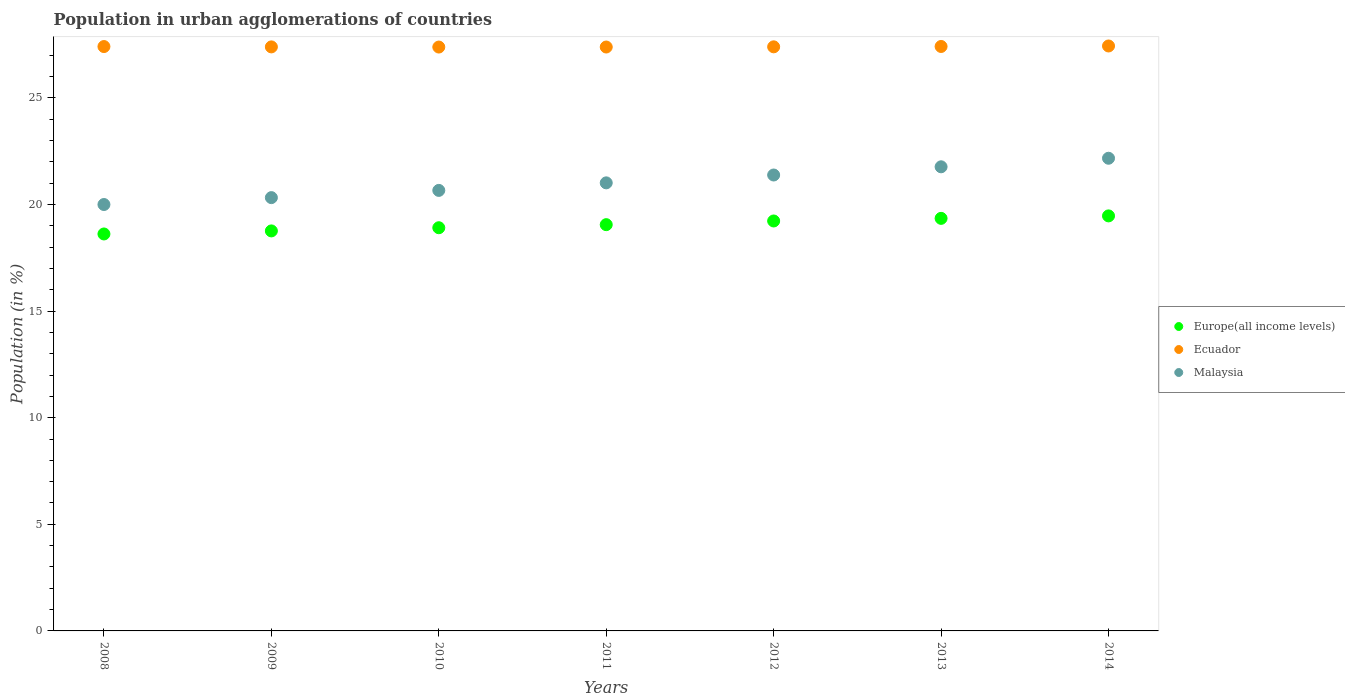How many different coloured dotlines are there?
Your response must be concise. 3. What is the percentage of population in urban agglomerations in Europe(all income levels) in 2010?
Provide a succinct answer. 18.91. Across all years, what is the maximum percentage of population in urban agglomerations in Malaysia?
Keep it short and to the point. 22.17. Across all years, what is the minimum percentage of population in urban agglomerations in Ecuador?
Keep it short and to the point. 27.39. In which year was the percentage of population in urban agglomerations in Ecuador minimum?
Offer a terse response. 2010. What is the total percentage of population in urban agglomerations in Ecuador in the graph?
Offer a very short reply. 191.82. What is the difference between the percentage of population in urban agglomerations in Europe(all income levels) in 2011 and that in 2013?
Your response must be concise. -0.3. What is the difference between the percentage of population in urban agglomerations in Ecuador in 2008 and the percentage of population in urban agglomerations in Malaysia in 2012?
Ensure brevity in your answer.  6.02. What is the average percentage of population in urban agglomerations in Ecuador per year?
Make the answer very short. 27.4. In the year 2008, what is the difference between the percentage of population in urban agglomerations in Europe(all income levels) and percentage of population in urban agglomerations in Malaysia?
Give a very brief answer. -1.38. What is the ratio of the percentage of population in urban agglomerations in Europe(all income levels) in 2009 to that in 2014?
Offer a very short reply. 0.96. What is the difference between the highest and the second highest percentage of population in urban agglomerations in Ecuador?
Keep it short and to the point. 0.02. What is the difference between the highest and the lowest percentage of population in urban agglomerations in Ecuador?
Ensure brevity in your answer.  0.05. Is the sum of the percentage of population in urban agglomerations in Malaysia in 2010 and 2011 greater than the maximum percentage of population in urban agglomerations in Ecuador across all years?
Offer a terse response. Yes. Is it the case that in every year, the sum of the percentage of population in urban agglomerations in Europe(all income levels) and percentage of population in urban agglomerations in Malaysia  is greater than the percentage of population in urban agglomerations in Ecuador?
Provide a succinct answer. Yes. Does the percentage of population in urban agglomerations in Ecuador monotonically increase over the years?
Make the answer very short. No. Is the percentage of population in urban agglomerations in Europe(all income levels) strictly less than the percentage of population in urban agglomerations in Malaysia over the years?
Your answer should be very brief. Yes. How many years are there in the graph?
Your answer should be very brief. 7. What is the title of the graph?
Provide a succinct answer. Population in urban agglomerations of countries. What is the label or title of the X-axis?
Your response must be concise. Years. What is the Population (in %) of Europe(all income levels) in 2008?
Your answer should be compact. 18.62. What is the Population (in %) of Ecuador in 2008?
Give a very brief answer. 27.41. What is the Population (in %) in Malaysia in 2008?
Give a very brief answer. 20. What is the Population (in %) of Europe(all income levels) in 2009?
Give a very brief answer. 18.76. What is the Population (in %) of Ecuador in 2009?
Your response must be concise. 27.39. What is the Population (in %) in Malaysia in 2009?
Provide a succinct answer. 20.32. What is the Population (in %) in Europe(all income levels) in 2010?
Make the answer very short. 18.91. What is the Population (in %) of Ecuador in 2010?
Make the answer very short. 27.39. What is the Population (in %) of Malaysia in 2010?
Your answer should be compact. 20.66. What is the Population (in %) in Europe(all income levels) in 2011?
Your answer should be compact. 19.06. What is the Population (in %) of Ecuador in 2011?
Your answer should be very brief. 27.39. What is the Population (in %) of Malaysia in 2011?
Keep it short and to the point. 21.02. What is the Population (in %) in Europe(all income levels) in 2012?
Provide a short and direct response. 19.23. What is the Population (in %) of Ecuador in 2012?
Offer a very short reply. 27.4. What is the Population (in %) of Malaysia in 2012?
Provide a short and direct response. 21.38. What is the Population (in %) of Europe(all income levels) in 2013?
Provide a short and direct response. 19.35. What is the Population (in %) in Ecuador in 2013?
Give a very brief answer. 27.41. What is the Population (in %) in Malaysia in 2013?
Give a very brief answer. 21.77. What is the Population (in %) of Europe(all income levels) in 2014?
Ensure brevity in your answer.  19.47. What is the Population (in %) of Ecuador in 2014?
Your response must be concise. 27.44. What is the Population (in %) of Malaysia in 2014?
Your answer should be very brief. 22.17. Across all years, what is the maximum Population (in %) in Europe(all income levels)?
Provide a short and direct response. 19.47. Across all years, what is the maximum Population (in %) in Ecuador?
Make the answer very short. 27.44. Across all years, what is the maximum Population (in %) in Malaysia?
Give a very brief answer. 22.17. Across all years, what is the minimum Population (in %) of Europe(all income levels)?
Your answer should be very brief. 18.62. Across all years, what is the minimum Population (in %) in Ecuador?
Your answer should be very brief. 27.39. Across all years, what is the minimum Population (in %) in Malaysia?
Your answer should be compact. 20. What is the total Population (in %) of Europe(all income levels) in the graph?
Your answer should be very brief. 133.39. What is the total Population (in %) of Ecuador in the graph?
Your response must be concise. 191.82. What is the total Population (in %) of Malaysia in the graph?
Provide a short and direct response. 147.32. What is the difference between the Population (in %) of Europe(all income levels) in 2008 and that in 2009?
Your answer should be compact. -0.14. What is the difference between the Population (in %) of Ecuador in 2008 and that in 2009?
Keep it short and to the point. 0.02. What is the difference between the Population (in %) of Malaysia in 2008 and that in 2009?
Give a very brief answer. -0.32. What is the difference between the Population (in %) of Europe(all income levels) in 2008 and that in 2010?
Your answer should be compact. -0.29. What is the difference between the Population (in %) in Ecuador in 2008 and that in 2010?
Ensure brevity in your answer.  0.02. What is the difference between the Population (in %) in Malaysia in 2008 and that in 2010?
Your answer should be compact. -0.66. What is the difference between the Population (in %) in Europe(all income levels) in 2008 and that in 2011?
Provide a succinct answer. -0.44. What is the difference between the Population (in %) in Ecuador in 2008 and that in 2011?
Your answer should be compact. 0.02. What is the difference between the Population (in %) of Malaysia in 2008 and that in 2011?
Your response must be concise. -1.02. What is the difference between the Population (in %) in Europe(all income levels) in 2008 and that in 2012?
Your response must be concise. -0.61. What is the difference between the Population (in %) of Ecuador in 2008 and that in 2012?
Offer a very short reply. 0.01. What is the difference between the Population (in %) of Malaysia in 2008 and that in 2012?
Your response must be concise. -1.38. What is the difference between the Population (in %) in Europe(all income levels) in 2008 and that in 2013?
Offer a terse response. -0.73. What is the difference between the Population (in %) of Ecuador in 2008 and that in 2013?
Provide a short and direct response. -0. What is the difference between the Population (in %) in Malaysia in 2008 and that in 2013?
Provide a succinct answer. -1.77. What is the difference between the Population (in %) of Europe(all income levels) in 2008 and that in 2014?
Give a very brief answer. -0.85. What is the difference between the Population (in %) of Ecuador in 2008 and that in 2014?
Provide a succinct answer. -0.03. What is the difference between the Population (in %) in Malaysia in 2008 and that in 2014?
Offer a very short reply. -2.17. What is the difference between the Population (in %) of Europe(all income levels) in 2009 and that in 2010?
Offer a very short reply. -0.15. What is the difference between the Population (in %) in Ecuador in 2009 and that in 2010?
Make the answer very short. 0.01. What is the difference between the Population (in %) of Malaysia in 2009 and that in 2010?
Your response must be concise. -0.34. What is the difference between the Population (in %) in Europe(all income levels) in 2009 and that in 2011?
Offer a very short reply. -0.29. What is the difference between the Population (in %) in Ecuador in 2009 and that in 2011?
Your answer should be very brief. 0.01. What is the difference between the Population (in %) of Malaysia in 2009 and that in 2011?
Your answer should be very brief. -0.69. What is the difference between the Population (in %) of Europe(all income levels) in 2009 and that in 2012?
Your response must be concise. -0.47. What is the difference between the Population (in %) of Ecuador in 2009 and that in 2012?
Make the answer very short. -0. What is the difference between the Population (in %) in Malaysia in 2009 and that in 2012?
Offer a very short reply. -1.06. What is the difference between the Population (in %) of Europe(all income levels) in 2009 and that in 2013?
Offer a very short reply. -0.59. What is the difference between the Population (in %) in Ecuador in 2009 and that in 2013?
Provide a short and direct response. -0.02. What is the difference between the Population (in %) of Malaysia in 2009 and that in 2013?
Offer a very short reply. -1.45. What is the difference between the Population (in %) of Europe(all income levels) in 2009 and that in 2014?
Give a very brief answer. -0.7. What is the difference between the Population (in %) of Ecuador in 2009 and that in 2014?
Ensure brevity in your answer.  -0.04. What is the difference between the Population (in %) of Malaysia in 2009 and that in 2014?
Ensure brevity in your answer.  -1.85. What is the difference between the Population (in %) in Europe(all income levels) in 2010 and that in 2011?
Your answer should be compact. -0.14. What is the difference between the Population (in %) in Ecuador in 2010 and that in 2011?
Provide a succinct answer. -0. What is the difference between the Population (in %) of Malaysia in 2010 and that in 2011?
Provide a succinct answer. -0.35. What is the difference between the Population (in %) in Europe(all income levels) in 2010 and that in 2012?
Provide a short and direct response. -0.32. What is the difference between the Population (in %) of Ecuador in 2010 and that in 2012?
Provide a succinct answer. -0.01. What is the difference between the Population (in %) of Malaysia in 2010 and that in 2012?
Provide a succinct answer. -0.72. What is the difference between the Population (in %) in Europe(all income levels) in 2010 and that in 2013?
Give a very brief answer. -0.44. What is the difference between the Population (in %) in Ecuador in 2010 and that in 2013?
Make the answer very short. -0.03. What is the difference between the Population (in %) in Malaysia in 2010 and that in 2013?
Provide a succinct answer. -1.11. What is the difference between the Population (in %) in Europe(all income levels) in 2010 and that in 2014?
Keep it short and to the point. -0.56. What is the difference between the Population (in %) in Ecuador in 2010 and that in 2014?
Provide a short and direct response. -0.05. What is the difference between the Population (in %) in Malaysia in 2010 and that in 2014?
Offer a terse response. -1.51. What is the difference between the Population (in %) in Europe(all income levels) in 2011 and that in 2012?
Provide a succinct answer. -0.17. What is the difference between the Population (in %) of Ecuador in 2011 and that in 2012?
Your answer should be very brief. -0.01. What is the difference between the Population (in %) of Malaysia in 2011 and that in 2012?
Your response must be concise. -0.37. What is the difference between the Population (in %) of Europe(all income levels) in 2011 and that in 2013?
Offer a terse response. -0.3. What is the difference between the Population (in %) in Ecuador in 2011 and that in 2013?
Your answer should be very brief. -0.03. What is the difference between the Population (in %) of Malaysia in 2011 and that in 2013?
Give a very brief answer. -0.75. What is the difference between the Population (in %) of Europe(all income levels) in 2011 and that in 2014?
Give a very brief answer. -0.41. What is the difference between the Population (in %) of Ecuador in 2011 and that in 2014?
Your response must be concise. -0.05. What is the difference between the Population (in %) in Malaysia in 2011 and that in 2014?
Give a very brief answer. -1.15. What is the difference between the Population (in %) of Europe(all income levels) in 2012 and that in 2013?
Give a very brief answer. -0.12. What is the difference between the Population (in %) in Ecuador in 2012 and that in 2013?
Provide a succinct answer. -0.02. What is the difference between the Population (in %) in Malaysia in 2012 and that in 2013?
Offer a terse response. -0.38. What is the difference between the Population (in %) in Europe(all income levels) in 2012 and that in 2014?
Keep it short and to the point. -0.24. What is the difference between the Population (in %) in Ecuador in 2012 and that in 2014?
Your answer should be compact. -0.04. What is the difference between the Population (in %) of Malaysia in 2012 and that in 2014?
Provide a short and direct response. -0.79. What is the difference between the Population (in %) of Europe(all income levels) in 2013 and that in 2014?
Your answer should be compact. -0.12. What is the difference between the Population (in %) of Ecuador in 2013 and that in 2014?
Give a very brief answer. -0.02. What is the difference between the Population (in %) of Malaysia in 2013 and that in 2014?
Your answer should be very brief. -0.4. What is the difference between the Population (in %) of Europe(all income levels) in 2008 and the Population (in %) of Ecuador in 2009?
Ensure brevity in your answer.  -8.77. What is the difference between the Population (in %) of Europe(all income levels) in 2008 and the Population (in %) of Malaysia in 2009?
Your answer should be compact. -1.7. What is the difference between the Population (in %) in Ecuador in 2008 and the Population (in %) in Malaysia in 2009?
Make the answer very short. 7.09. What is the difference between the Population (in %) in Europe(all income levels) in 2008 and the Population (in %) in Ecuador in 2010?
Provide a short and direct response. -8.77. What is the difference between the Population (in %) in Europe(all income levels) in 2008 and the Population (in %) in Malaysia in 2010?
Provide a succinct answer. -2.04. What is the difference between the Population (in %) of Ecuador in 2008 and the Population (in %) of Malaysia in 2010?
Offer a terse response. 6.75. What is the difference between the Population (in %) of Europe(all income levels) in 2008 and the Population (in %) of Ecuador in 2011?
Your answer should be compact. -8.77. What is the difference between the Population (in %) of Europe(all income levels) in 2008 and the Population (in %) of Malaysia in 2011?
Provide a short and direct response. -2.4. What is the difference between the Population (in %) of Ecuador in 2008 and the Population (in %) of Malaysia in 2011?
Offer a terse response. 6.39. What is the difference between the Population (in %) of Europe(all income levels) in 2008 and the Population (in %) of Ecuador in 2012?
Your response must be concise. -8.78. What is the difference between the Population (in %) of Europe(all income levels) in 2008 and the Population (in %) of Malaysia in 2012?
Your response must be concise. -2.77. What is the difference between the Population (in %) in Ecuador in 2008 and the Population (in %) in Malaysia in 2012?
Give a very brief answer. 6.02. What is the difference between the Population (in %) of Europe(all income levels) in 2008 and the Population (in %) of Ecuador in 2013?
Provide a short and direct response. -8.79. What is the difference between the Population (in %) of Europe(all income levels) in 2008 and the Population (in %) of Malaysia in 2013?
Give a very brief answer. -3.15. What is the difference between the Population (in %) of Ecuador in 2008 and the Population (in %) of Malaysia in 2013?
Offer a very short reply. 5.64. What is the difference between the Population (in %) of Europe(all income levels) in 2008 and the Population (in %) of Ecuador in 2014?
Make the answer very short. -8.82. What is the difference between the Population (in %) in Europe(all income levels) in 2008 and the Population (in %) in Malaysia in 2014?
Give a very brief answer. -3.55. What is the difference between the Population (in %) in Ecuador in 2008 and the Population (in %) in Malaysia in 2014?
Provide a short and direct response. 5.24. What is the difference between the Population (in %) of Europe(all income levels) in 2009 and the Population (in %) of Ecuador in 2010?
Provide a succinct answer. -8.62. What is the difference between the Population (in %) in Europe(all income levels) in 2009 and the Population (in %) in Malaysia in 2010?
Offer a terse response. -1.9. What is the difference between the Population (in %) of Ecuador in 2009 and the Population (in %) of Malaysia in 2010?
Provide a short and direct response. 6.73. What is the difference between the Population (in %) of Europe(all income levels) in 2009 and the Population (in %) of Ecuador in 2011?
Your response must be concise. -8.63. What is the difference between the Population (in %) of Europe(all income levels) in 2009 and the Population (in %) of Malaysia in 2011?
Offer a very short reply. -2.25. What is the difference between the Population (in %) in Ecuador in 2009 and the Population (in %) in Malaysia in 2011?
Offer a very short reply. 6.38. What is the difference between the Population (in %) in Europe(all income levels) in 2009 and the Population (in %) in Ecuador in 2012?
Provide a succinct answer. -8.63. What is the difference between the Population (in %) of Europe(all income levels) in 2009 and the Population (in %) of Malaysia in 2012?
Keep it short and to the point. -2.62. What is the difference between the Population (in %) in Ecuador in 2009 and the Population (in %) in Malaysia in 2012?
Make the answer very short. 6.01. What is the difference between the Population (in %) of Europe(all income levels) in 2009 and the Population (in %) of Ecuador in 2013?
Your answer should be compact. -8.65. What is the difference between the Population (in %) in Europe(all income levels) in 2009 and the Population (in %) in Malaysia in 2013?
Make the answer very short. -3.01. What is the difference between the Population (in %) of Ecuador in 2009 and the Population (in %) of Malaysia in 2013?
Give a very brief answer. 5.62. What is the difference between the Population (in %) of Europe(all income levels) in 2009 and the Population (in %) of Ecuador in 2014?
Ensure brevity in your answer.  -8.67. What is the difference between the Population (in %) in Europe(all income levels) in 2009 and the Population (in %) in Malaysia in 2014?
Your answer should be compact. -3.41. What is the difference between the Population (in %) of Ecuador in 2009 and the Population (in %) of Malaysia in 2014?
Provide a short and direct response. 5.22. What is the difference between the Population (in %) of Europe(all income levels) in 2010 and the Population (in %) of Ecuador in 2011?
Your response must be concise. -8.48. What is the difference between the Population (in %) of Europe(all income levels) in 2010 and the Population (in %) of Malaysia in 2011?
Provide a short and direct response. -2.1. What is the difference between the Population (in %) of Ecuador in 2010 and the Population (in %) of Malaysia in 2011?
Keep it short and to the point. 6.37. What is the difference between the Population (in %) in Europe(all income levels) in 2010 and the Population (in %) in Ecuador in 2012?
Your response must be concise. -8.48. What is the difference between the Population (in %) of Europe(all income levels) in 2010 and the Population (in %) of Malaysia in 2012?
Make the answer very short. -2.47. What is the difference between the Population (in %) of Ecuador in 2010 and the Population (in %) of Malaysia in 2012?
Provide a short and direct response. 6. What is the difference between the Population (in %) of Europe(all income levels) in 2010 and the Population (in %) of Ecuador in 2013?
Ensure brevity in your answer.  -8.5. What is the difference between the Population (in %) of Europe(all income levels) in 2010 and the Population (in %) of Malaysia in 2013?
Make the answer very short. -2.86. What is the difference between the Population (in %) of Ecuador in 2010 and the Population (in %) of Malaysia in 2013?
Provide a succinct answer. 5.62. What is the difference between the Population (in %) in Europe(all income levels) in 2010 and the Population (in %) in Ecuador in 2014?
Make the answer very short. -8.53. What is the difference between the Population (in %) in Europe(all income levels) in 2010 and the Population (in %) in Malaysia in 2014?
Provide a short and direct response. -3.26. What is the difference between the Population (in %) of Ecuador in 2010 and the Population (in %) of Malaysia in 2014?
Provide a short and direct response. 5.22. What is the difference between the Population (in %) of Europe(all income levels) in 2011 and the Population (in %) of Ecuador in 2012?
Your answer should be compact. -8.34. What is the difference between the Population (in %) in Europe(all income levels) in 2011 and the Population (in %) in Malaysia in 2012?
Your response must be concise. -2.33. What is the difference between the Population (in %) of Ecuador in 2011 and the Population (in %) of Malaysia in 2012?
Offer a terse response. 6. What is the difference between the Population (in %) of Europe(all income levels) in 2011 and the Population (in %) of Ecuador in 2013?
Your answer should be very brief. -8.36. What is the difference between the Population (in %) of Europe(all income levels) in 2011 and the Population (in %) of Malaysia in 2013?
Make the answer very short. -2.71. What is the difference between the Population (in %) in Ecuador in 2011 and the Population (in %) in Malaysia in 2013?
Offer a terse response. 5.62. What is the difference between the Population (in %) of Europe(all income levels) in 2011 and the Population (in %) of Ecuador in 2014?
Your answer should be very brief. -8.38. What is the difference between the Population (in %) of Europe(all income levels) in 2011 and the Population (in %) of Malaysia in 2014?
Ensure brevity in your answer.  -3.11. What is the difference between the Population (in %) in Ecuador in 2011 and the Population (in %) in Malaysia in 2014?
Keep it short and to the point. 5.22. What is the difference between the Population (in %) in Europe(all income levels) in 2012 and the Population (in %) in Ecuador in 2013?
Your response must be concise. -8.18. What is the difference between the Population (in %) of Europe(all income levels) in 2012 and the Population (in %) of Malaysia in 2013?
Your answer should be compact. -2.54. What is the difference between the Population (in %) in Ecuador in 2012 and the Population (in %) in Malaysia in 2013?
Offer a very short reply. 5.63. What is the difference between the Population (in %) in Europe(all income levels) in 2012 and the Population (in %) in Ecuador in 2014?
Offer a very short reply. -8.21. What is the difference between the Population (in %) of Europe(all income levels) in 2012 and the Population (in %) of Malaysia in 2014?
Offer a very short reply. -2.94. What is the difference between the Population (in %) of Ecuador in 2012 and the Population (in %) of Malaysia in 2014?
Your answer should be very brief. 5.23. What is the difference between the Population (in %) in Europe(all income levels) in 2013 and the Population (in %) in Ecuador in 2014?
Offer a terse response. -8.09. What is the difference between the Population (in %) in Europe(all income levels) in 2013 and the Population (in %) in Malaysia in 2014?
Your response must be concise. -2.82. What is the difference between the Population (in %) of Ecuador in 2013 and the Population (in %) of Malaysia in 2014?
Your answer should be compact. 5.24. What is the average Population (in %) in Europe(all income levels) per year?
Make the answer very short. 19.06. What is the average Population (in %) of Ecuador per year?
Make the answer very short. 27.4. What is the average Population (in %) in Malaysia per year?
Offer a very short reply. 21.05. In the year 2008, what is the difference between the Population (in %) in Europe(all income levels) and Population (in %) in Ecuador?
Make the answer very short. -8.79. In the year 2008, what is the difference between the Population (in %) of Europe(all income levels) and Population (in %) of Malaysia?
Give a very brief answer. -1.38. In the year 2008, what is the difference between the Population (in %) of Ecuador and Population (in %) of Malaysia?
Your response must be concise. 7.41. In the year 2009, what is the difference between the Population (in %) of Europe(all income levels) and Population (in %) of Ecuador?
Your response must be concise. -8.63. In the year 2009, what is the difference between the Population (in %) of Europe(all income levels) and Population (in %) of Malaysia?
Offer a very short reply. -1.56. In the year 2009, what is the difference between the Population (in %) in Ecuador and Population (in %) in Malaysia?
Make the answer very short. 7.07. In the year 2010, what is the difference between the Population (in %) in Europe(all income levels) and Population (in %) in Ecuador?
Offer a terse response. -8.47. In the year 2010, what is the difference between the Population (in %) in Europe(all income levels) and Population (in %) in Malaysia?
Provide a succinct answer. -1.75. In the year 2010, what is the difference between the Population (in %) of Ecuador and Population (in %) of Malaysia?
Your answer should be very brief. 6.72. In the year 2011, what is the difference between the Population (in %) of Europe(all income levels) and Population (in %) of Ecuador?
Offer a very short reply. -8.33. In the year 2011, what is the difference between the Population (in %) in Europe(all income levels) and Population (in %) in Malaysia?
Your response must be concise. -1.96. In the year 2011, what is the difference between the Population (in %) of Ecuador and Population (in %) of Malaysia?
Make the answer very short. 6.37. In the year 2012, what is the difference between the Population (in %) of Europe(all income levels) and Population (in %) of Ecuador?
Ensure brevity in your answer.  -8.17. In the year 2012, what is the difference between the Population (in %) in Europe(all income levels) and Population (in %) in Malaysia?
Offer a very short reply. -2.16. In the year 2012, what is the difference between the Population (in %) in Ecuador and Population (in %) in Malaysia?
Make the answer very short. 6.01. In the year 2013, what is the difference between the Population (in %) in Europe(all income levels) and Population (in %) in Ecuador?
Ensure brevity in your answer.  -8.06. In the year 2013, what is the difference between the Population (in %) of Europe(all income levels) and Population (in %) of Malaysia?
Your response must be concise. -2.42. In the year 2013, what is the difference between the Population (in %) of Ecuador and Population (in %) of Malaysia?
Provide a short and direct response. 5.64. In the year 2014, what is the difference between the Population (in %) of Europe(all income levels) and Population (in %) of Ecuador?
Keep it short and to the point. -7.97. In the year 2014, what is the difference between the Population (in %) in Europe(all income levels) and Population (in %) in Malaysia?
Keep it short and to the point. -2.7. In the year 2014, what is the difference between the Population (in %) in Ecuador and Population (in %) in Malaysia?
Your response must be concise. 5.27. What is the ratio of the Population (in %) of Europe(all income levels) in 2008 to that in 2009?
Ensure brevity in your answer.  0.99. What is the ratio of the Population (in %) in Malaysia in 2008 to that in 2009?
Offer a very short reply. 0.98. What is the ratio of the Population (in %) in Europe(all income levels) in 2008 to that in 2010?
Offer a very short reply. 0.98. What is the ratio of the Population (in %) in Malaysia in 2008 to that in 2010?
Provide a succinct answer. 0.97. What is the ratio of the Population (in %) of Europe(all income levels) in 2008 to that in 2011?
Keep it short and to the point. 0.98. What is the ratio of the Population (in %) in Ecuador in 2008 to that in 2011?
Give a very brief answer. 1. What is the ratio of the Population (in %) of Malaysia in 2008 to that in 2011?
Give a very brief answer. 0.95. What is the ratio of the Population (in %) in Europe(all income levels) in 2008 to that in 2012?
Your answer should be very brief. 0.97. What is the ratio of the Population (in %) of Malaysia in 2008 to that in 2012?
Keep it short and to the point. 0.94. What is the ratio of the Population (in %) in Europe(all income levels) in 2008 to that in 2013?
Offer a very short reply. 0.96. What is the ratio of the Population (in %) of Ecuador in 2008 to that in 2013?
Offer a very short reply. 1. What is the ratio of the Population (in %) of Malaysia in 2008 to that in 2013?
Ensure brevity in your answer.  0.92. What is the ratio of the Population (in %) of Europe(all income levels) in 2008 to that in 2014?
Your response must be concise. 0.96. What is the ratio of the Population (in %) in Ecuador in 2008 to that in 2014?
Make the answer very short. 1. What is the ratio of the Population (in %) of Malaysia in 2008 to that in 2014?
Make the answer very short. 0.9. What is the ratio of the Population (in %) of Malaysia in 2009 to that in 2010?
Keep it short and to the point. 0.98. What is the ratio of the Population (in %) in Europe(all income levels) in 2009 to that in 2011?
Your response must be concise. 0.98. What is the ratio of the Population (in %) in Malaysia in 2009 to that in 2011?
Offer a very short reply. 0.97. What is the ratio of the Population (in %) of Europe(all income levels) in 2009 to that in 2012?
Provide a short and direct response. 0.98. What is the ratio of the Population (in %) in Ecuador in 2009 to that in 2012?
Give a very brief answer. 1. What is the ratio of the Population (in %) of Malaysia in 2009 to that in 2012?
Provide a succinct answer. 0.95. What is the ratio of the Population (in %) of Europe(all income levels) in 2009 to that in 2013?
Your response must be concise. 0.97. What is the ratio of the Population (in %) of Ecuador in 2009 to that in 2013?
Your answer should be compact. 1. What is the ratio of the Population (in %) of Malaysia in 2009 to that in 2013?
Give a very brief answer. 0.93. What is the ratio of the Population (in %) of Europe(all income levels) in 2009 to that in 2014?
Make the answer very short. 0.96. What is the ratio of the Population (in %) in Europe(all income levels) in 2010 to that in 2011?
Your response must be concise. 0.99. What is the ratio of the Population (in %) in Malaysia in 2010 to that in 2011?
Ensure brevity in your answer.  0.98. What is the ratio of the Population (in %) of Europe(all income levels) in 2010 to that in 2012?
Your answer should be compact. 0.98. What is the ratio of the Population (in %) of Ecuador in 2010 to that in 2012?
Provide a short and direct response. 1. What is the ratio of the Population (in %) of Malaysia in 2010 to that in 2012?
Give a very brief answer. 0.97. What is the ratio of the Population (in %) in Europe(all income levels) in 2010 to that in 2013?
Ensure brevity in your answer.  0.98. What is the ratio of the Population (in %) of Malaysia in 2010 to that in 2013?
Provide a short and direct response. 0.95. What is the ratio of the Population (in %) in Europe(all income levels) in 2010 to that in 2014?
Provide a short and direct response. 0.97. What is the ratio of the Population (in %) in Malaysia in 2010 to that in 2014?
Keep it short and to the point. 0.93. What is the ratio of the Population (in %) in Europe(all income levels) in 2011 to that in 2012?
Ensure brevity in your answer.  0.99. What is the ratio of the Population (in %) of Ecuador in 2011 to that in 2012?
Your response must be concise. 1. What is the ratio of the Population (in %) in Malaysia in 2011 to that in 2012?
Ensure brevity in your answer.  0.98. What is the ratio of the Population (in %) in Europe(all income levels) in 2011 to that in 2013?
Ensure brevity in your answer.  0.98. What is the ratio of the Population (in %) of Malaysia in 2011 to that in 2013?
Offer a very short reply. 0.97. What is the ratio of the Population (in %) in Europe(all income levels) in 2011 to that in 2014?
Your response must be concise. 0.98. What is the ratio of the Population (in %) of Malaysia in 2011 to that in 2014?
Your answer should be very brief. 0.95. What is the ratio of the Population (in %) in Ecuador in 2012 to that in 2013?
Ensure brevity in your answer.  1. What is the ratio of the Population (in %) in Malaysia in 2012 to that in 2013?
Your answer should be very brief. 0.98. What is the ratio of the Population (in %) of Europe(all income levels) in 2012 to that in 2014?
Your answer should be compact. 0.99. What is the ratio of the Population (in %) in Malaysia in 2012 to that in 2014?
Offer a very short reply. 0.96. What is the ratio of the Population (in %) in Malaysia in 2013 to that in 2014?
Your response must be concise. 0.98. What is the difference between the highest and the second highest Population (in %) in Europe(all income levels)?
Provide a succinct answer. 0.12. What is the difference between the highest and the second highest Population (in %) of Ecuador?
Your response must be concise. 0.02. What is the difference between the highest and the second highest Population (in %) in Malaysia?
Provide a short and direct response. 0.4. What is the difference between the highest and the lowest Population (in %) in Europe(all income levels)?
Give a very brief answer. 0.85. What is the difference between the highest and the lowest Population (in %) in Ecuador?
Give a very brief answer. 0.05. What is the difference between the highest and the lowest Population (in %) of Malaysia?
Your answer should be compact. 2.17. 